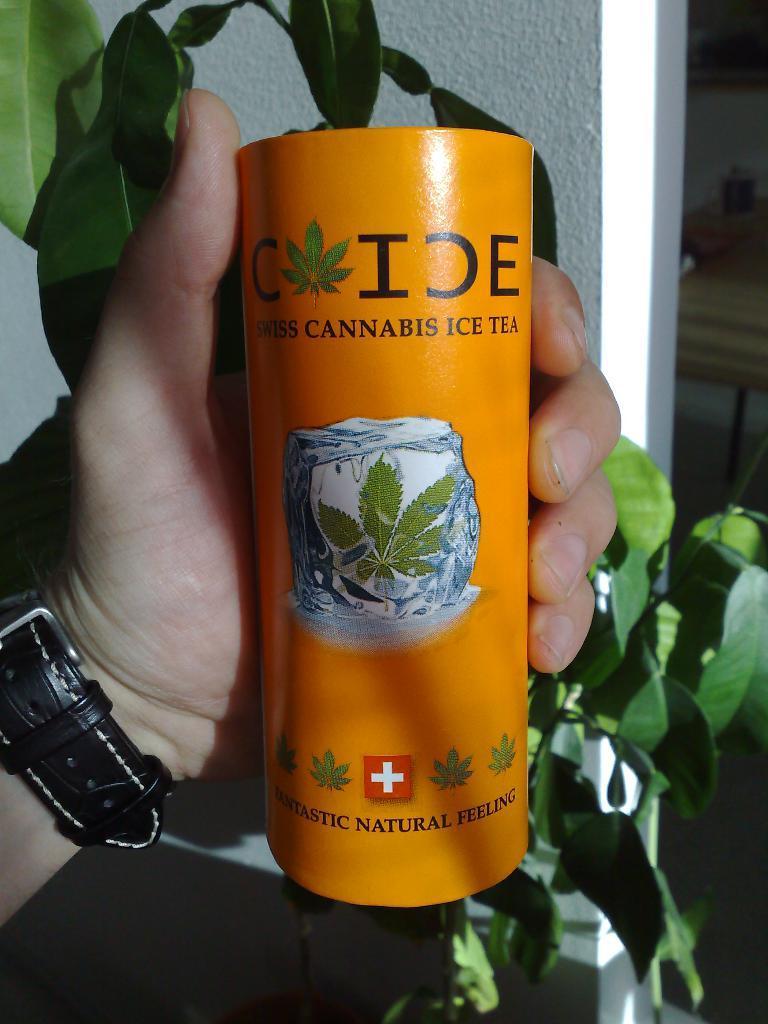How would you summarize this image in a sentence or two? In this picture we can see a person is holding a tin, there is some text on the tin, in the background we can see a wall and a plant, this person wore a wrist watch. 